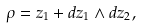<formula> <loc_0><loc_0><loc_500><loc_500>\rho = z _ { 1 } + d z _ { 1 } \wedge d z _ { 2 } ,</formula> 